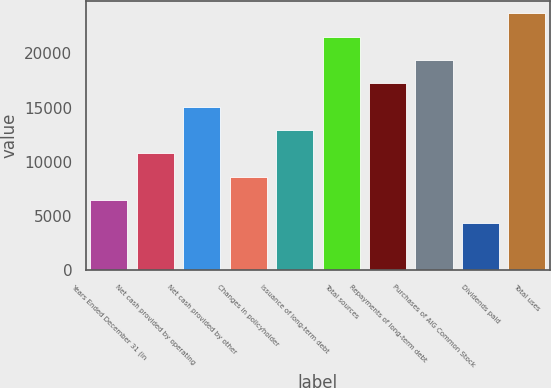Convert chart to OTSL. <chart><loc_0><loc_0><loc_500><loc_500><bar_chart><fcel>Years Ended December 31 (in<fcel>Net cash provided by operating<fcel>Net cash provided by other<fcel>Changes in policyholder<fcel>Issuance of long-term debt<fcel>Total sources<fcel>Repayments of long-term debt<fcel>Purchases of AIG Common Stock<fcel>Dividends paid<fcel>Total uses<nl><fcel>6484.5<fcel>10781.5<fcel>15078.5<fcel>8633<fcel>12930<fcel>21524<fcel>17227<fcel>19375.5<fcel>4336<fcel>23672.5<nl></chart> 